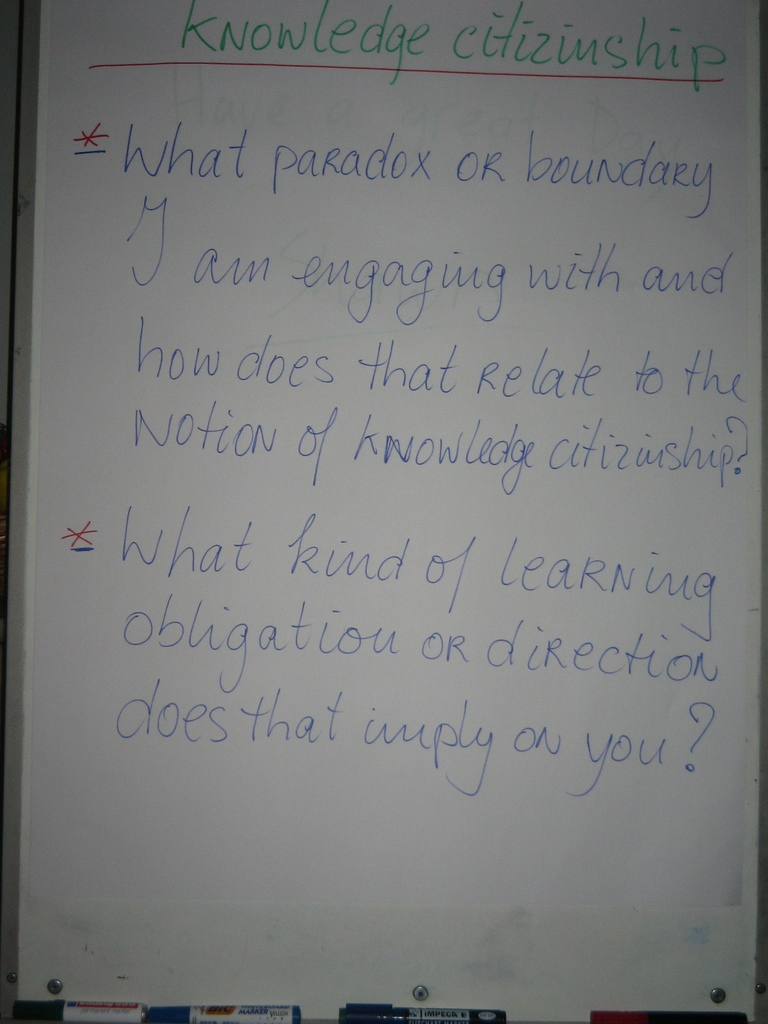What strategies could educators use to encourage students to become 'knowledge citizens'? Educators could design collaborative projects where students contribute to a collective knowledge base, prompt discussions that require critical thinking and personal reflection, and encourage peer-to-peer teaching opportunities. Providing an open platform for students to share insights and questions publicly, and integrating real-world problem-solving into the curriculum, are also effective strategies for cultivating knowledge citizenship. 